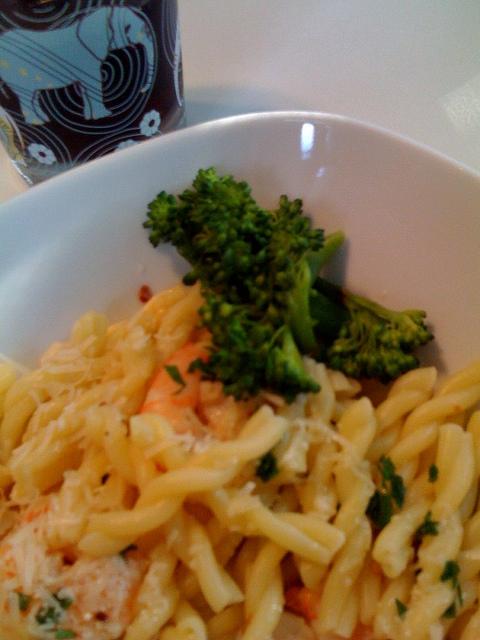What animal is pictured on the cup?
Be succinct. Elephant. What is the vegetable?
Short answer required. Broccoli. What kind of pasta is used in the dish?
Give a very brief answer. Macaroni. Is this meal served on a plate?
Quick response, please. No. What is the green vegetable?
Quick response, please. Broccoli. What kind of pasta was used for this dish?
Be succinct. Spiral. 